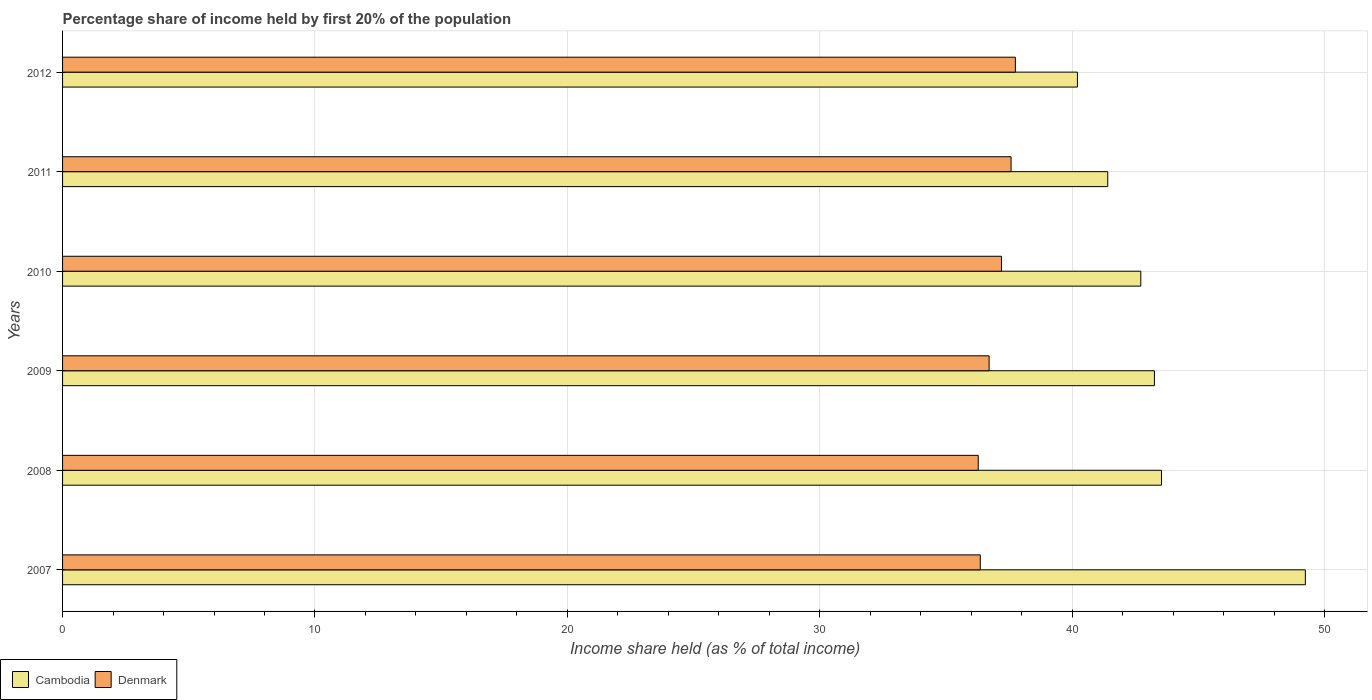Are the number of bars per tick equal to the number of legend labels?
Provide a short and direct response. Yes. How many bars are there on the 1st tick from the top?
Offer a terse response. 2. What is the share of income held by first 20% of the population in Cambodia in 2009?
Give a very brief answer. 43.26. Across all years, what is the maximum share of income held by first 20% of the population in Cambodia?
Give a very brief answer. 49.24. Across all years, what is the minimum share of income held by first 20% of the population in Denmark?
Keep it short and to the point. 36.28. In which year was the share of income held by first 20% of the population in Denmark maximum?
Offer a terse response. 2012. What is the total share of income held by first 20% of the population in Cambodia in the graph?
Provide a succinct answer. 260.38. What is the difference between the share of income held by first 20% of the population in Denmark in 2007 and that in 2008?
Provide a succinct answer. 0.08. What is the difference between the share of income held by first 20% of the population in Cambodia in 2008 and the share of income held by first 20% of the population in Denmark in 2012?
Give a very brief answer. 5.79. What is the average share of income held by first 20% of the population in Cambodia per year?
Provide a succinct answer. 43.4. In the year 2008, what is the difference between the share of income held by first 20% of the population in Denmark and share of income held by first 20% of the population in Cambodia?
Keep it short and to the point. -7.26. What is the ratio of the share of income held by first 20% of the population in Cambodia in 2008 to that in 2011?
Your answer should be compact. 1.05. Is the share of income held by first 20% of the population in Denmark in 2007 less than that in 2009?
Provide a short and direct response. Yes. What is the difference between the highest and the second highest share of income held by first 20% of the population in Denmark?
Give a very brief answer. 0.17. What is the difference between the highest and the lowest share of income held by first 20% of the population in Cambodia?
Offer a terse response. 9.03. In how many years, is the share of income held by first 20% of the population in Denmark greater than the average share of income held by first 20% of the population in Denmark taken over all years?
Provide a short and direct response. 3. What does the 1st bar from the top in 2009 represents?
Your answer should be very brief. Denmark. What does the 1st bar from the bottom in 2009 represents?
Make the answer very short. Cambodia. How many years are there in the graph?
Give a very brief answer. 6. Does the graph contain grids?
Offer a terse response. Yes. Where does the legend appear in the graph?
Provide a short and direct response. Bottom left. How many legend labels are there?
Ensure brevity in your answer.  2. How are the legend labels stacked?
Ensure brevity in your answer.  Horizontal. What is the title of the graph?
Your response must be concise. Percentage share of income held by first 20% of the population. What is the label or title of the X-axis?
Provide a short and direct response. Income share held (as % of total income). What is the label or title of the Y-axis?
Your response must be concise. Years. What is the Income share held (as % of total income) of Cambodia in 2007?
Offer a very short reply. 49.24. What is the Income share held (as % of total income) of Denmark in 2007?
Ensure brevity in your answer.  36.36. What is the Income share held (as % of total income) in Cambodia in 2008?
Your answer should be very brief. 43.54. What is the Income share held (as % of total income) in Denmark in 2008?
Offer a very short reply. 36.28. What is the Income share held (as % of total income) in Cambodia in 2009?
Make the answer very short. 43.26. What is the Income share held (as % of total income) in Denmark in 2009?
Ensure brevity in your answer.  36.71. What is the Income share held (as % of total income) in Cambodia in 2010?
Give a very brief answer. 42.72. What is the Income share held (as % of total income) of Denmark in 2010?
Offer a very short reply. 37.2. What is the Income share held (as % of total income) in Cambodia in 2011?
Your answer should be very brief. 41.41. What is the Income share held (as % of total income) of Denmark in 2011?
Provide a short and direct response. 37.58. What is the Income share held (as % of total income) of Cambodia in 2012?
Offer a terse response. 40.21. What is the Income share held (as % of total income) of Denmark in 2012?
Ensure brevity in your answer.  37.75. Across all years, what is the maximum Income share held (as % of total income) in Cambodia?
Offer a very short reply. 49.24. Across all years, what is the maximum Income share held (as % of total income) in Denmark?
Give a very brief answer. 37.75. Across all years, what is the minimum Income share held (as % of total income) in Cambodia?
Your answer should be compact. 40.21. Across all years, what is the minimum Income share held (as % of total income) in Denmark?
Ensure brevity in your answer.  36.28. What is the total Income share held (as % of total income) of Cambodia in the graph?
Your answer should be compact. 260.38. What is the total Income share held (as % of total income) in Denmark in the graph?
Your response must be concise. 221.88. What is the difference between the Income share held (as % of total income) in Denmark in 2007 and that in 2008?
Offer a terse response. 0.08. What is the difference between the Income share held (as % of total income) of Cambodia in 2007 and that in 2009?
Your response must be concise. 5.98. What is the difference between the Income share held (as % of total income) of Denmark in 2007 and that in 2009?
Ensure brevity in your answer.  -0.35. What is the difference between the Income share held (as % of total income) in Cambodia in 2007 and that in 2010?
Offer a very short reply. 6.52. What is the difference between the Income share held (as % of total income) of Denmark in 2007 and that in 2010?
Ensure brevity in your answer.  -0.84. What is the difference between the Income share held (as % of total income) of Cambodia in 2007 and that in 2011?
Ensure brevity in your answer.  7.83. What is the difference between the Income share held (as % of total income) of Denmark in 2007 and that in 2011?
Your answer should be very brief. -1.22. What is the difference between the Income share held (as % of total income) of Cambodia in 2007 and that in 2012?
Provide a succinct answer. 9.03. What is the difference between the Income share held (as % of total income) in Denmark in 2007 and that in 2012?
Keep it short and to the point. -1.39. What is the difference between the Income share held (as % of total income) of Cambodia in 2008 and that in 2009?
Offer a very short reply. 0.28. What is the difference between the Income share held (as % of total income) in Denmark in 2008 and that in 2009?
Offer a very short reply. -0.43. What is the difference between the Income share held (as % of total income) in Cambodia in 2008 and that in 2010?
Provide a succinct answer. 0.82. What is the difference between the Income share held (as % of total income) of Denmark in 2008 and that in 2010?
Ensure brevity in your answer.  -0.92. What is the difference between the Income share held (as % of total income) in Cambodia in 2008 and that in 2011?
Offer a very short reply. 2.13. What is the difference between the Income share held (as % of total income) in Cambodia in 2008 and that in 2012?
Make the answer very short. 3.33. What is the difference between the Income share held (as % of total income) in Denmark in 2008 and that in 2012?
Your answer should be very brief. -1.47. What is the difference between the Income share held (as % of total income) of Cambodia in 2009 and that in 2010?
Make the answer very short. 0.54. What is the difference between the Income share held (as % of total income) of Denmark in 2009 and that in 2010?
Make the answer very short. -0.49. What is the difference between the Income share held (as % of total income) of Cambodia in 2009 and that in 2011?
Ensure brevity in your answer.  1.85. What is the difference between the Income share held (as % of total income) of Denmark in 2009 and that in 2011?
Your response must be concise. -0.87. What is the difference between the Income share held (as % of total income) of Cambodia in 2009 and that in 2012?
Give a very brief answer. 3.05. What is the difference between the Income share held (as % of total income) in Denmark in 2009 and that in 2012?
Provide a short and direct response. -1.04. What is the difference between the Income share held (as % of total income) in Cambodia in 2010 and that in 2011?
Make the answer very short. 1.31. What is the difference between the Income share held (as % of total income) in Denmark in 2010 and that in 2011?
Keep it short and to the point. -0.38. What is the difference between the Income share held (as % of total income) in Cambodia in 2010 and that in 2012?
Your response must be concise. 2.51. What is the difference between the Income share held (as % of total income) in Denmark in 2010 and that in 2012?
Your response must be concise. -0.55. What is the difference between the Income share held (as % of total income) in Denmark in 2011 and that in 2012?
Give a very brief answer. -0.17. What is the difference between the Income share held (as % of total income) in Cambodia in 2007 and the Income share held (as % of total income) in Denmark in 2008?
Make the answer very short. 12.96. What is the difference between the Income share held (as % of total income) in Cambodia in 2007 and the Income share held (as % of total income) in Denmark in 2009?
Your response must be concise. 12.53. What is the difference between the Income share held (as % of total income) in Cambodia in 2007 and the Income share held (as % of total income) in Denmark in 2010?
Provide a succinct answer. 12.04. What is the difference between the Income share held (as % of total income) in Cambodia in 2007 and the Income share held (as % of total income) in Denmark in 2011?
Offer a terse response. 11.66. What is the difference between the Income share held (as % of total income) of Cambodia in 2007 and the Income share held (as % of total income) of Denmark in 2012?
Your response must be concise. 11.49. What is the difference between the Income share held (as % of total income) of Cambodia in 2008 and the Income share held (as % of total income) of Denmark in 2009?
Make the answer very short. 6.83. What is the difference between the Income share held (as % of total income) of Cambodia in 2008 and the Income share held (as % of total income) of Denmark in 2010?
Make the answer very short. 6.34. What is the difference between the Income share held (as % of total income) of Cambodia in 2008 and the Income share held (as % of total income) of Denmark in 2011?
Your answer should be very brief. 5.96. What is the difference between the Income share held (as % of total income) in Cambodia in 2008 and the Income share held (as % of total income) in Denmark in 2012?
Give a very brief answer. 5.79. What is the difference between the Income share held (as % of total income) of Cambodia in 2009 and the Income share held (as % of total income) of Denmark in 2010?
Keep it short and to the point. 6.06. What is the difference between the Income share held (as % of total income) in Cambodia in 2009 and the Income share held (as % of total income) in Denmark in 2011?
Offer a very short reply. 5.68. What is the difference between the Income share held (as % of total income) of Cambodia in 2009 and the Income share held (as % of total income) of Denmark in 2012?
Your answer should be compact. 5.51. What is the difference between the Income share held (as % of total income) in Cambodia in 2010 and the Income share held (as % of total income) in Denmark in 2011?
Provide a succinct answer. 5.14. What is the difference between the Income share held (as % of total income) of Cambodia in 2010 and the Income share held (as % of total income) of Denmark in 2012?
Keep it short and to the point. 4.97. What is the difference between the Income share held (as % of total income) in Cambodia in 2011 and the Income share held (as % of total income) in Denmark in 2012?
Make the answer very short. 3.66. What is the average Income share held (as % of total income) in Cambodia per year?
Offer a very short reply. 43.4. What is the average Income share held (as % of total income) of Denmark per year?
Your answer should be compact. 36.98. In the year 2007, what is the difference between the Income share held (as % of total income) of Cambodia and Income share held (as % of total income) of Denmark?
Offer a very short reply. 12.88. In the year 2008, what is the difference between the Income share held (as % of total income) of Cambodia and Income share held (as % of total income) of Denmark?
Give a very brief answer. 7.26. In the year 2009, what is the difference between the Income share held (as % of total income) of Cambodia and Income share held (as % of total income) of Denmark?
Give a very brief answer. 6.55. In the year 2010, what is the difference between the Income share held (as % of total income) in Cambodia and Income share held (as % of total income) in Denmark?
Your response must be concise. 5.52. In the year 2011, what is the difference between the Income share held (as % of total income) of Cambodia and Income share held (as % of total income) of Denmark?
Your answer should be very brief. 3.83. In the year 2012, what is the difference between the Income share held (as % of total income) of Cambodia and Income share held (as % of total income) of Denmark?
Offer a terse response. 2.46. What is the ratio of the Income share held (as % of total income) in Cambodia in 2007 to that in 2008?
Provide a short and direct response. 1.13. What is the ratio of the Income share held (as % of total income) in Cambodia in 2007 to that in 2009?
Offer a very short reply. 1.14. What is the ratio of the Income share held (as % of total income) in Cambodia in 2007 to that in 2010?
Offer a very short reply. 1.15. What is the ratio of the Income share held (as % of total income) of Denmark in 2007 to that in 2010?
Make the answer very short. 0.98. What is the ratio of the Income share held (as % of total income) in Cambodia in 2007 to that in 2011?
Give a very brief answer. 1.19. What is the ratio of the Income share held (as % of total income) of Denmark in 2007 to that in 2011?
Provide a short and direct response. 0.97. What is the ratio of the Income share held (as % of total income) of Cambodia in 2007 to that in 2012?
Your answer should be compact. 1.22. What is the ratio of the Income share held (as % of total income) in Denmark in 2007 to that in 2012?
Keep it short and to the point. 0.96. What is the ratio of the Income share held (as % of total income) of Cambodia in 2008 to that in 2009?
Offer a terse response. 1.01. What is the ratio of the Income share held (as % of total income) of Denmark in 2008 to that in 2009?
Provide a short and direct response. 0.99. What is the ratio of the Income share held (as % of total income) of Cambodia in 2008 to that in 2010?
Offer a very short reply. 1.02. What is the ratio of the Income share held (as % of total income) in Denmark in 2008 to that in 2010?
Offer a very short reply. 0.98. What is the ratio of the Income share held (as % of total income) in Cambodia in 2008 to that in 2011?
Give a very brief answer. 1.05. What is the ratio of the Income share held (as % of total income) in Denmark in 2008 to that in 2011?
Give a very brief answer. 0.97. What is the ratio of the Income share held (as % of total income) of Cambodia in 2008 to that in 2012?
Your response must be concise. 1.08. What is the ratio of the Income share held (as % of total income) in Denmark in 2008 to that in 2012?
Provide a short and direct response. 0.96. What is the ratio of the Income share held (as % of total income) in Cambodia in 2009 to that in 2010?
Make the answer very short. 1.01. What is the ratio of the Income share held (as % of total income) in Denmark in 2009 to that in 2010?
Your answer should be very brief. 0.99. What is the ratio of the Income share held (as % of total income) in Cambodia in 2009 to that in 2011?
Provide a succinct answer. 1.04. What is the ratio of the Income share held (as % of total income) of Denmark in 2009 to that in 2011?
Your response must be concise. 0.98. What is the ratio of the Income share held (as % of total income) in Cambodia in 2009 to that in 2012?
Give a very brief answer. 1.08. What is the ratio of the Income share held (as % of total income) in Denmark in 2009 to that in 2012?
Keep it short and to the point. 0.97. What is the ratio of the Income share held (as % of total income) in Cambodia in 2010 to that in 2011?
Make the answer very short. 1.03. What is the ratio of the Income share held (as % of total income) in Denmark in 2010 to that in 2011?
Keep it short and to the point. 0.99. What is the ratio of the Income share held (as % of total income) of Cambodia in 2010 to that in 2012?
Keep it short and to the point. 1.06. What is the ratio of the Income share held (as % of total income) of Denmark in 2010 to that in 2012?
Ensure brevity in your answer.  0.99. What is the ratio of the Income share held (as % of total income) in Cambodia in 2011 to that in 2012?
Make the answer very short. 1.03. What is the difference between the highest and the second highest Income share held (as % of total income) of Denmark?
Offer a very short reply. 0.17. What is the difference between the highest and the lowest Income share held (as % of total income) in Cambodia?
Provide a succinct answer. 9.03. What is the difference between the highest and the lowest Income share held (as % of total income) in Denmark?
Make the answer very short. 1.47. 